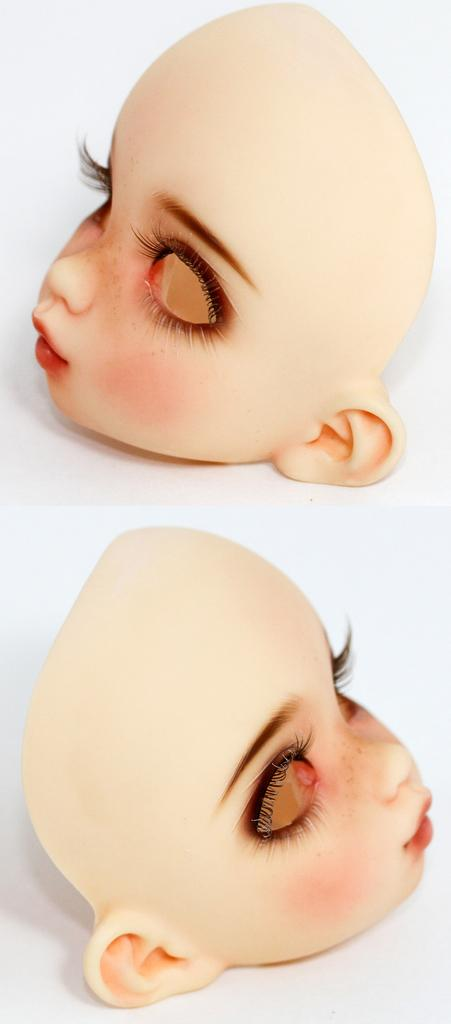How many dolls are present in the image? There are two dolls in the image. What can be seen on the dolls? The faces of the dolls are visible. What color is the background of the image? The background of the image is white. What color are the faces of the dolls? The faces of the dolls are in cream color. What year is depicted in the image? The image does not depict a specific year; it is a still image of two dolls. What type of home is shown in the image? The image does not show a home; it is a close-up of two dolls with a white background. 